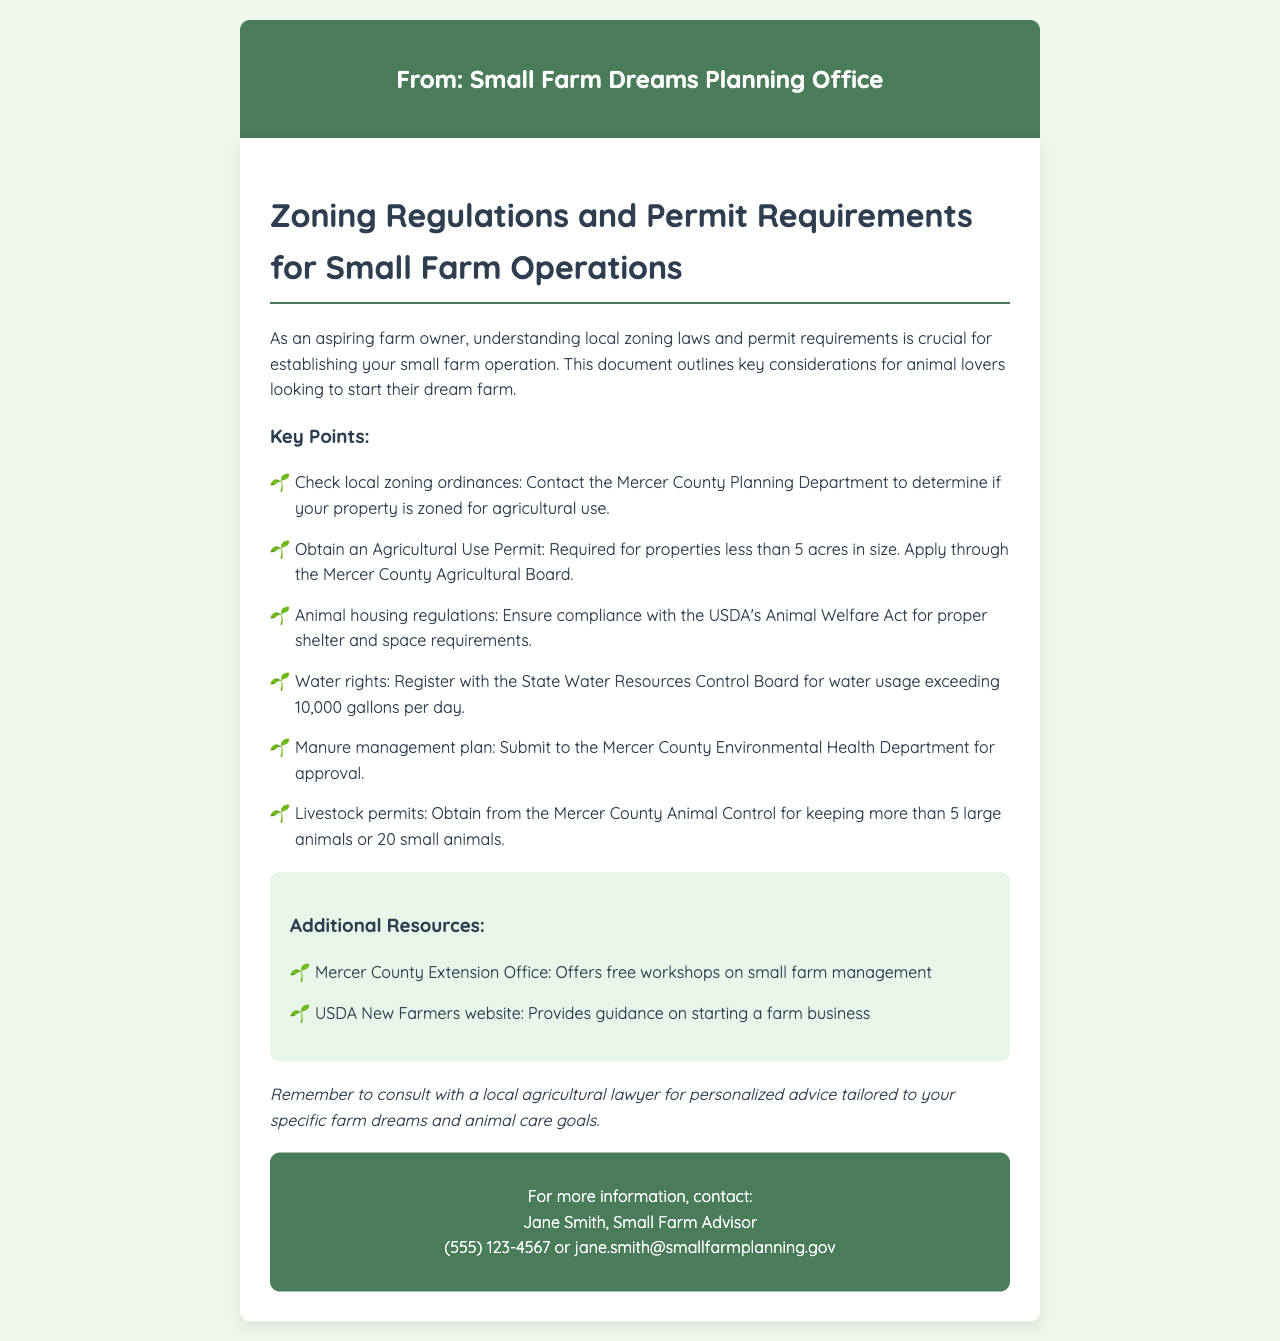What is the source of the fax? The fax is from the Small Farm Dreams Planning Office, as stated in the document header.
Answer: Small Farm Dreams Planning Office Which department must be contacted to check local zoning ordinances? The document mentions contacting the Mercer County Planning Department for zoning ordinances.
Answer: Mercer County Planning Department What permit is required for properties less than 5 acres? The fax indicates that an Agricultural Use Permit is required for smaller properties.
Answer: Agricultural Use Permit Who must be consulted for a manure management plan? According to the document, the Mercer County Environmental Health Department must approve the manure management plan.
Answer: Mercer County Environmental Health Department What is the maximum number of large animals before a special permit is needed? The document states that a livestock permit is required for keeping more than 5 large animals.
Answer: 5 large animals How many gallons per day must be registered for water usage? The fax mentions a registration requirement for water usage exceeding 10,000 gallons per day.
Answer: 10,000 gallons What kind of workshops does the Mercer County Extension Office offer? The document states that the Mercer County Extension Office offers free workshops on small farm management.
Answer: Free workshops on small farm management Who is the contact person for more information? The document provides Jane Smith as the contact person for additional information.
Answer: Jane Smith What act must animal housing regulations comply with? The fax notes that compliance with the USDA's Animal Welfare Act is necessary for animal housing.
Answer: USDA's Animal Welfare Act 